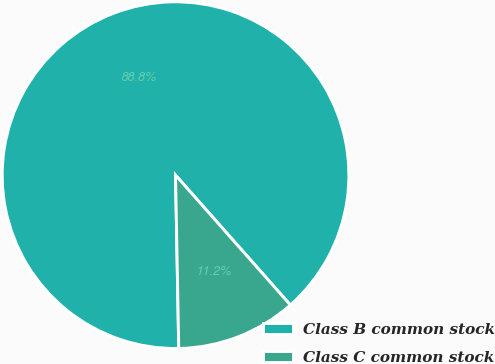Convert chart to OTSL. <chart><loc_0><loc_0><loc_500><loc_500><pie_chart><fcel>Class B common stock<fcel>Class C common stock<nl><fcel>88.77%<fcel>11.23%<nl></chart> 